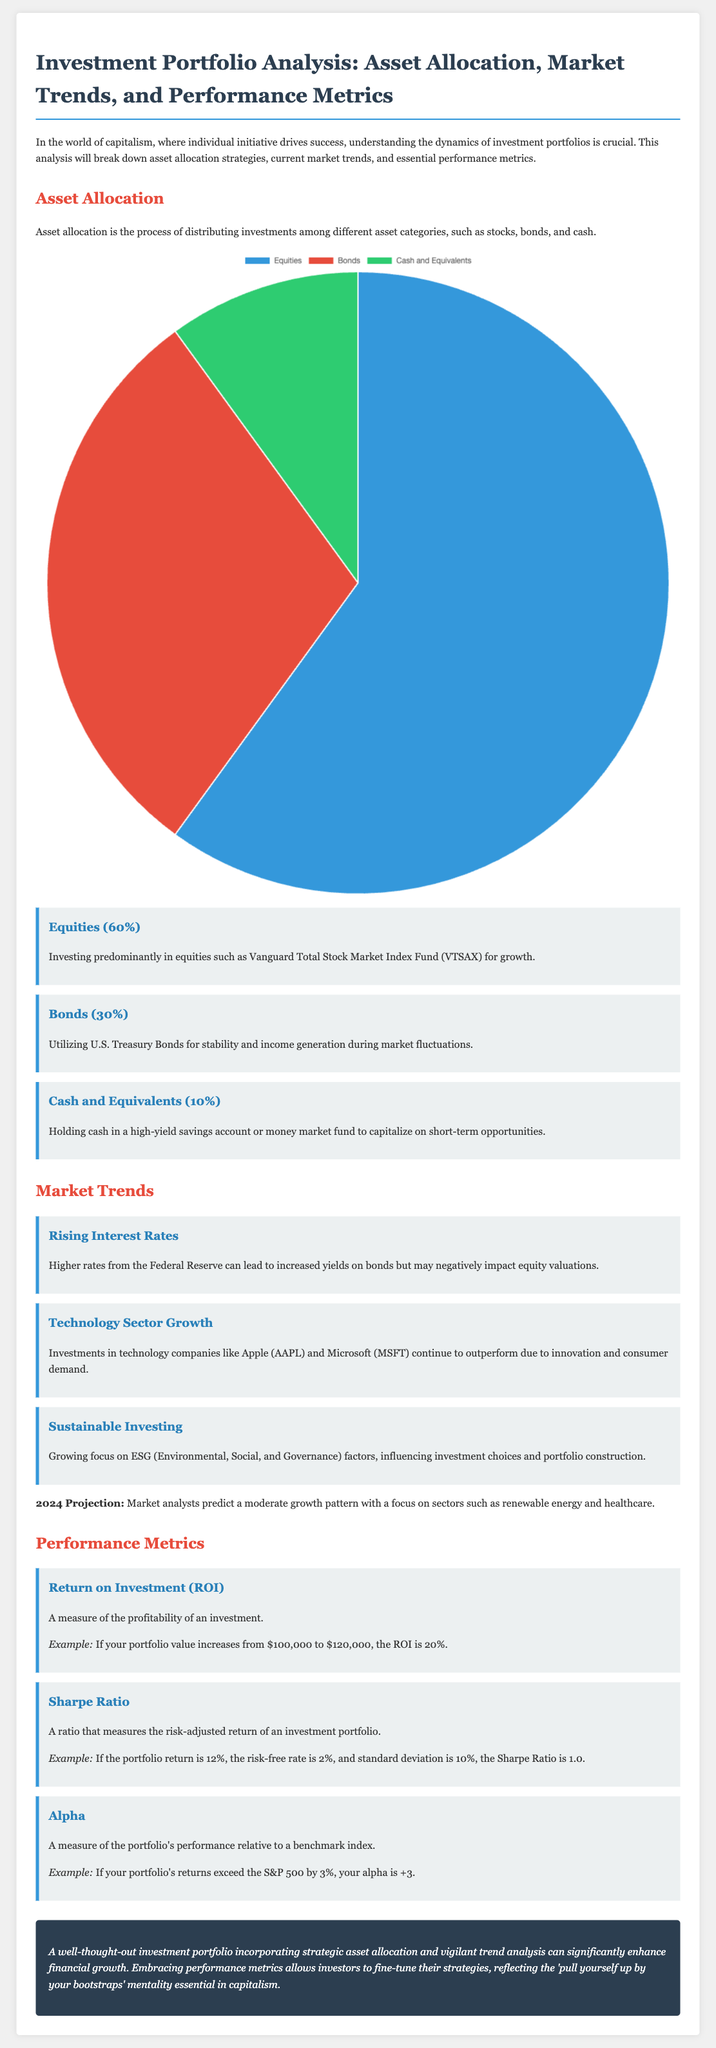What percentage of the portfolio is allocated to Equities? The document states that the portfolio has an allocation of 60% to Equities.
Answer: 60% What investment is suggested for stability? The document mentions utilizing U.S. Treasury Bonds for stability.
Answer: U.S. Treasury Bonds What is the expected market trend for 2024? The document predicts a moderate growth pattern with a focus on renewable energy and healthcare sectors.
Answer: Moderate growth pattern What is the ROI example given in the document? The document provides an example where the portfolio value increases from $100,000 to $120,000, resulting in a 20% ROI.
Answer: 20% What does the Sharpe Ratio measure? The document states that the Sharpe Ratio measures the risk-adjusted return of an investment portfolio.
Answer: Risk-adjusted return What percentage of the portfolio is allocated to Cash and Equivalents? The document specifies that Cash and Equivalents make up 10% of the portfolio.
Answer: 10% What investment focus is growing according to the document? The document highlights a growing focus on ESG (Environmental, Social, and Governance) factors.
Answer: ESG factors What is the Alpha measure used for? The document explains that Alpha measures the portfolio's performance relative to a benchmark index.
Answer: Performance relative to a benchmark index 